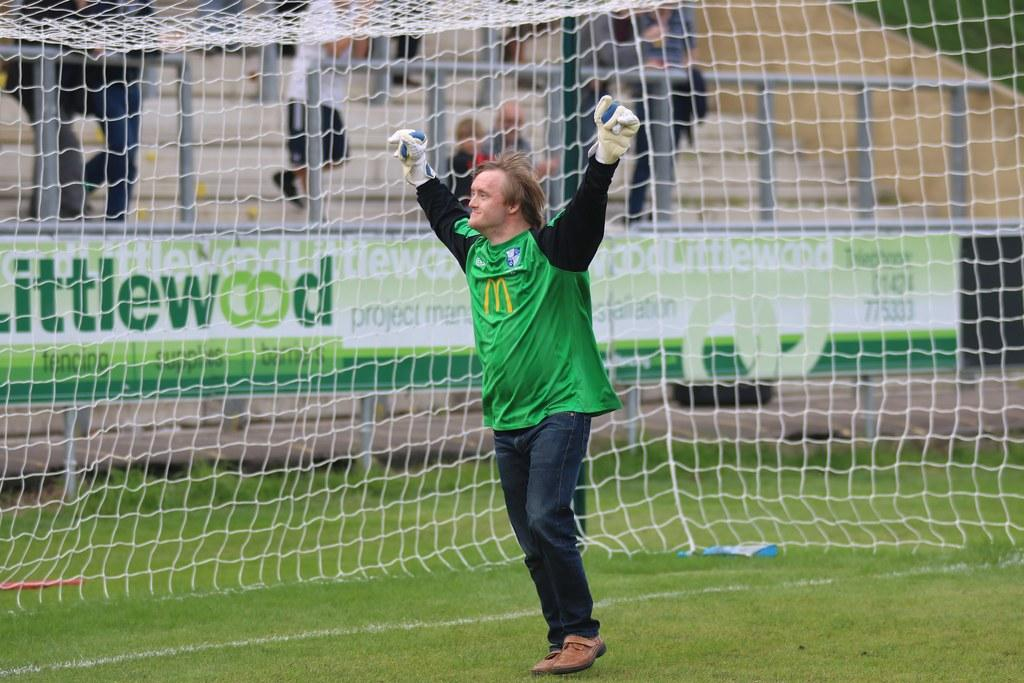<image>
Create a compact narrative representing the image presented. A goalie with a yellow M on his shirt raises his hands over his head. 